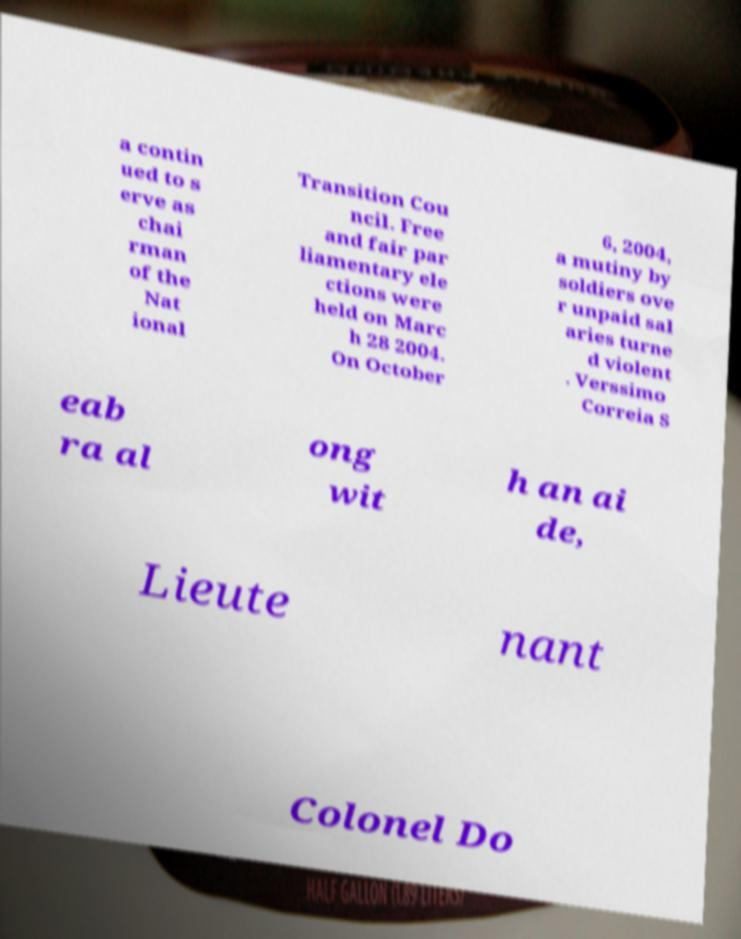Please read and relay the text visible in this image. What does it say? a contin ued to s erve as chai rman of the Nat ional Transition Cou ncil. Free and fair par liamentary ele ctions were held on Marc h 28 2004. On October 6, 2004, a mutiny by soldiers ove r unpaid sal aries turne d violent . Verssimo Correia S eab ra al ong wit h an ai de, Lieute nant Colonel Do 